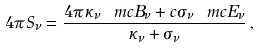Convert formula to latex. <formula><loc_0><loc_0><loc_500><loc_500>4 \pi S _ { \nu } = \frac { 4 \pi \kappa _ { \nu } \ m c { B } _ { \nu } + c \sigma _ { \nu } \ m c { E } _ { \nu } } { \kappa _ { \nu } + \sigma _ { \nu } } \, ,</formula> 